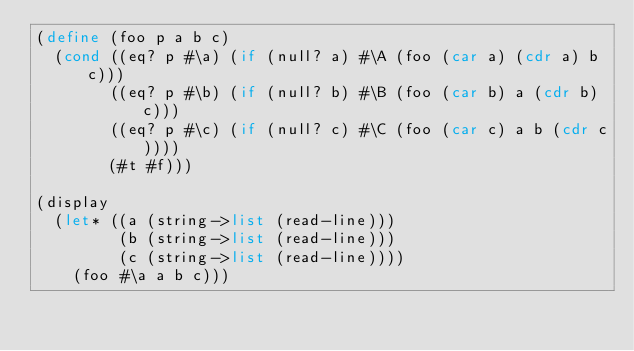<code> <loc_0><loc_0><loc_500><loc_500><_Scheme_>(define (foo p a b c)
  (cond ((eq? p #\a) (if (null? a) #\A (foo (car a) (cdr a) b c)))
        ((eq? p #\b) (if (null? b) #\B (foo (car b) a (cdr b) c)))
        ((eq? p #\c) (if (null? c) #\C (foo (car c) a b (cdr c))))
        (#t #f)))

(display
  (let* ((a (string->list (read-line)))
         (b (string->list (read-line)))
         (c (string->list (read-line))))
    (foo #\a a b c)))
</code> 